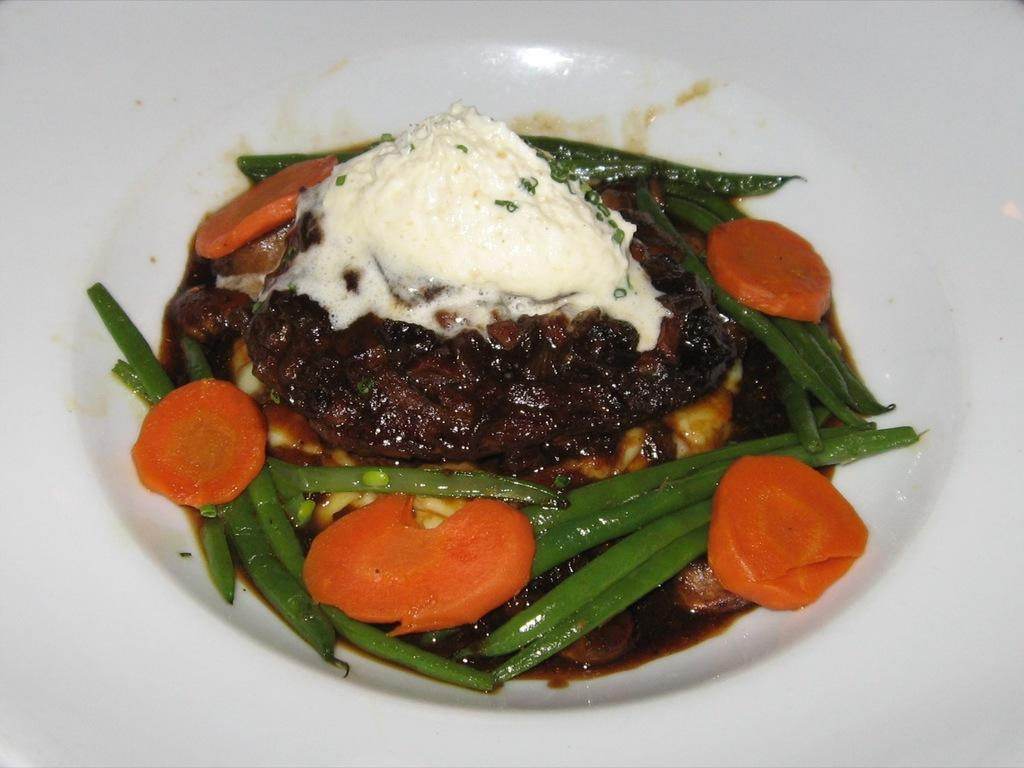What is on the plate that is visible in the image? There are carrots, ice cream, meat, and beans on the plate in the image. What color is the plate? The plate is white. Can you describe the different types of food on the plate? There are carrots, ice cream, meat, and beans on the plate. What type of throne is depicted in the image? There is no throne present in the image; it features a plate with various types of food. How does the digestion process of the beans on the plate work? The image does not show the digestion process of the beans; it only shows the beans on the plate. 